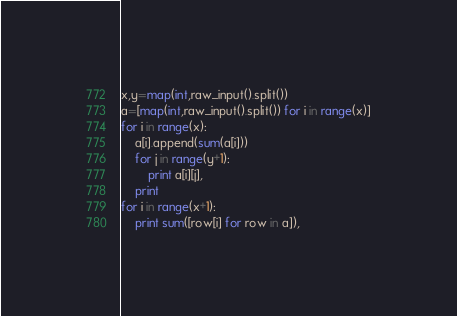<code> <loc_0><loc_0><loc_500><loc_500><_Python_>x,y=map(int,raw_input().split())
a=[map(int,raw_input().split()) for i in range(x)]
for i in range(x):
	a[i].append(sum(a[i]))
	for j in range(y+1):
		print a[i][j],
	print
for i in range(x+1):
	print sum([row[i] for row in a]),</code> 